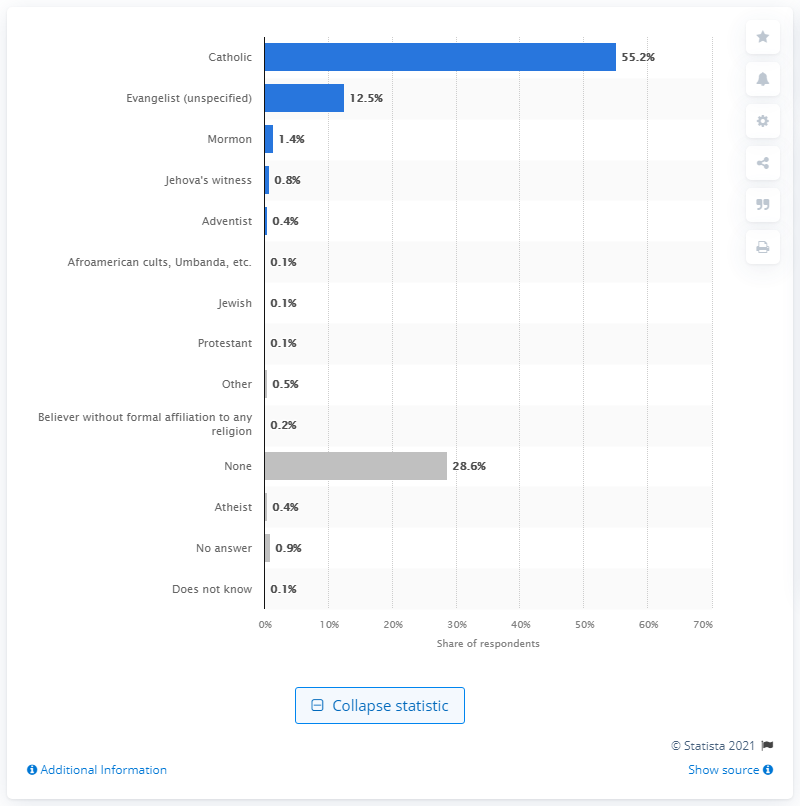Give some essential details in this illustration. According to a survey conducted in Chile, only 0.4% of the population identified as atheist. 